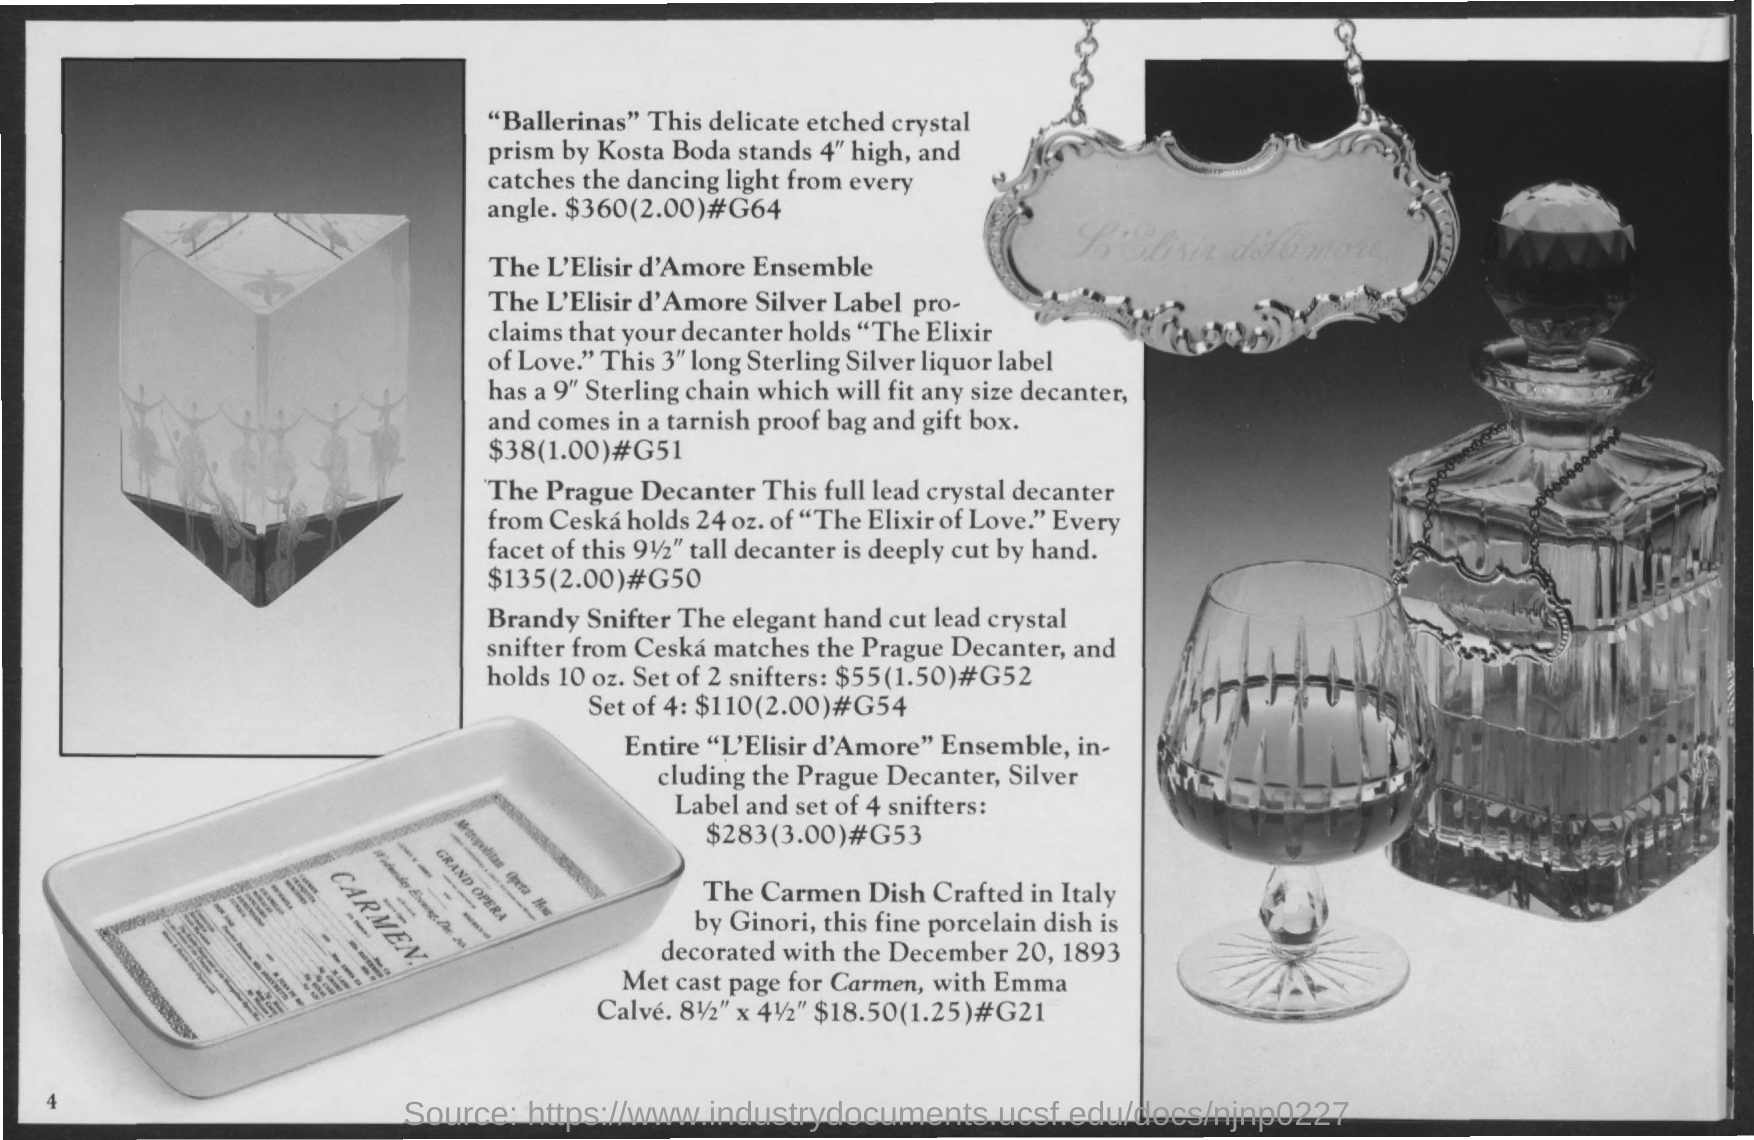Identify some key points in this picture. The cost of "Ballerinas" is $360. The Prague Decanter is available for a cost of $135. 